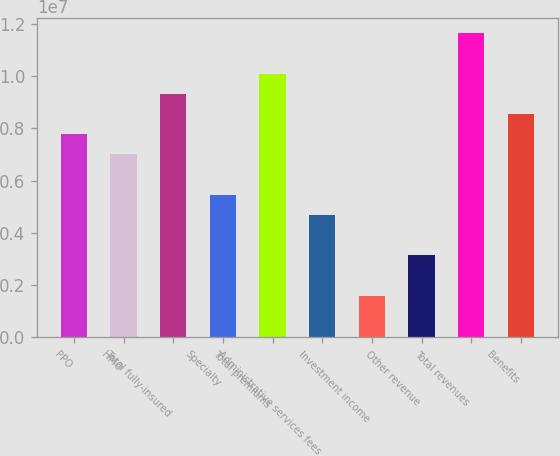Convert chart to OTSL. <chart><loc_0><loc_0><loc_500><loc_500><bar_chart><fcel>PPO<fcel>HMO<fcel>Total fully-insured<fcel>Specialty<fcel>Total premiums<fcel>Administrative services fees<fcel>Investment income<fcel>Other revenue<fcel>Total revenues<fcel>Benefits<nl><fcel>7.77536e+06<fcel>7.00279e+06<fcel>9.32049e+06<fcel>5.45765e+06<fcel>1.00931e+07<fcel>4.68508e+06<fcel>1.5948e+06<fcel>3.13994e+06<fcel>1.16382e+07<fcel>8.54792e+06<nl></chart> 